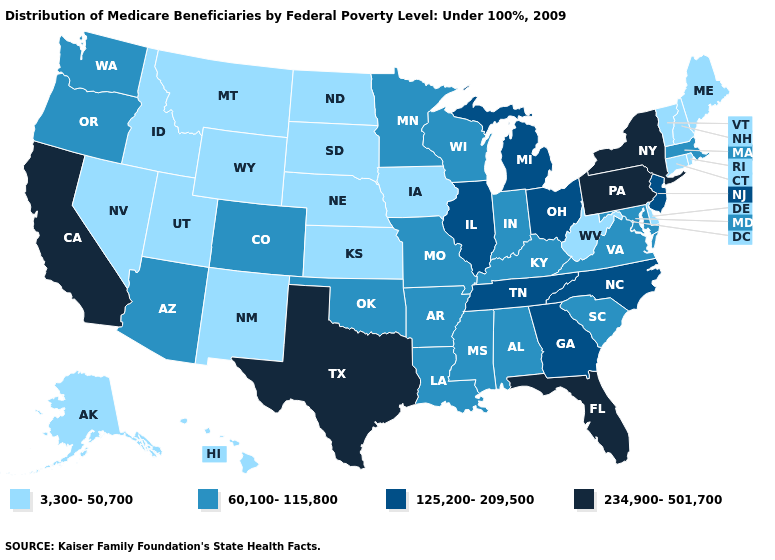Does the first symbol in the legend represent the smallest category?
Quick response, please. Yes. Does Mississippi have the highest value in the USA?
Be succinct. No. Does Idaho have a lower value than Connecticut?
Give a very brief answer. No. Which states have the lowest value in the USA?
Concise answer only. Alaska, Connecticut, Delaware, Hawaii, Idaho, Iowa, Kansas, Maine, Montana, Nebraska, Nevada, New Hampshire, New Mexico, North Dakota, Rhode Island, South Dakota, Utah, Vermont, West Virginia, Wyoming. Does Connecticut have a lower value than West Virginia?
Write a very short answer. No. Name the states that have a value in the range 3,300-50,700?
Concise answer only. Alaska, Connecticut, Delaware, Hawaii, Idaho, Iowa, Kansas, Maine, Montana, Nebraska, Nevada, New Hampshire, New Mexico, North Dakota, Rhode Island, South Dakota, Utah, Vermont, West Virginia, Wyoming. How many symbols are there in the legend?
Give a very brief answer. 4. Name the states that have a value in the range 60,100-115,800?
Short answer required. Alabama, Arizona, Arkansas, Colorado, Indiana, Kentucky, Louisiana, Maryland, Massachusetts, Minnesota, Mississippi, Missouri, Oklahoma, Oregon, South Carolina, Virginia, Washington, Wisconsin. Which states hav the highest value in the South?
Quick response, please. Florida, Texas. Name the states that have a value in the range 125,200-209,500?
Answer briefly. Georgia, Illinois, Michigan, New Jersey, North Carolina, Ohio, Tennessee. Name the states that have a value in the range 234,900-501,700?
Answer briefly. California, Florida, New York, Pennsylvania, Texas. What is the lowest value in the USA?
Give a very brief answer. 3,300-50,700. Which states have the highest value in the USA?
Short answer required. California, Florida, New York, Pennsylvania, Texas. What is the lowest value in the USA?
Answer briefly. 3,300-50,700. Name the states that have a value in the range 125,200-209,500?
Write a very short answer. Georgia, Illinois, Michigan, New Jersey, North Carolina, Ohio, Tennessee. 